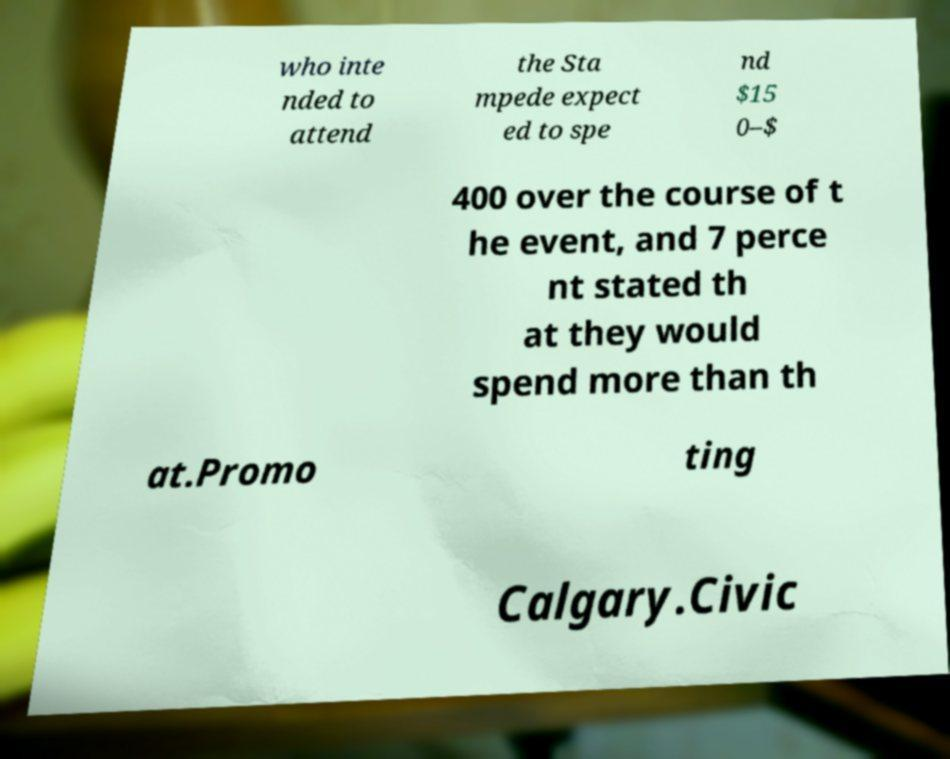Could you extract and type out the text from this image? who inte nded to attend the Sta mpede expect ed to spe nd $15 0–$ 400 over the course of t he event, and 7 perce nt stated th at they would spend more than th at.Promo ting Calgary.Civic 